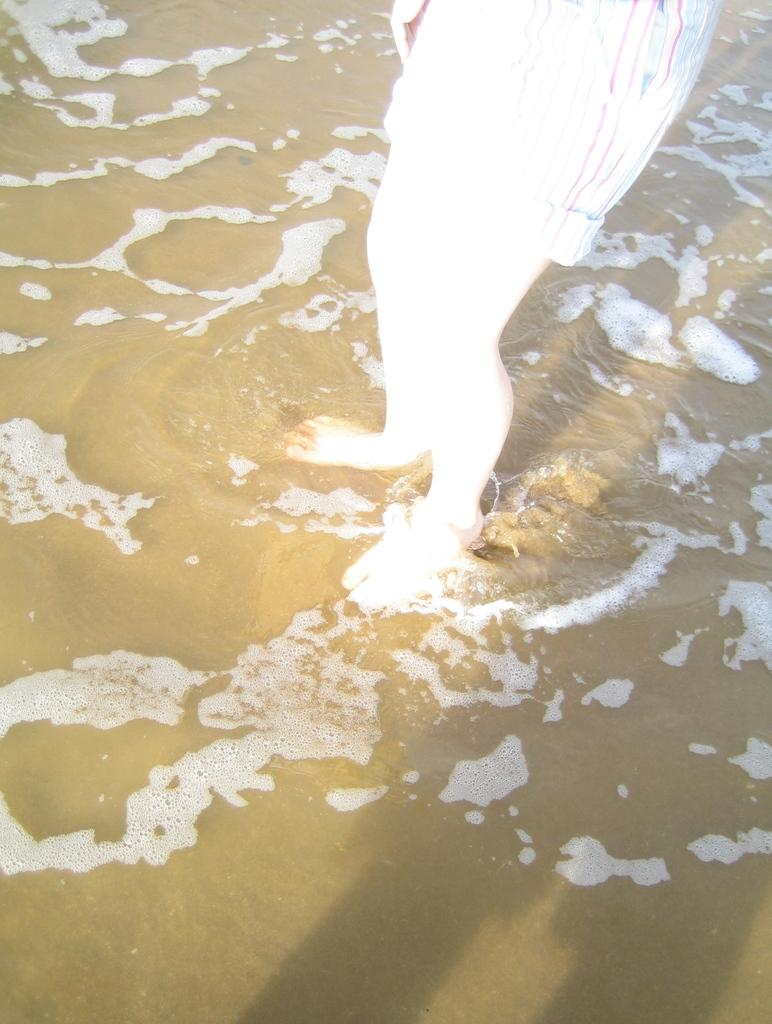Who is present in the image? There is a person in the image. What is the person wearing? The person is wearing a dress. Where is the person located in the image? The person is standing in the water. What advice does the parent give to the expert in the image? There is no parent or expert present in the image, so no such interaction can be observed. 